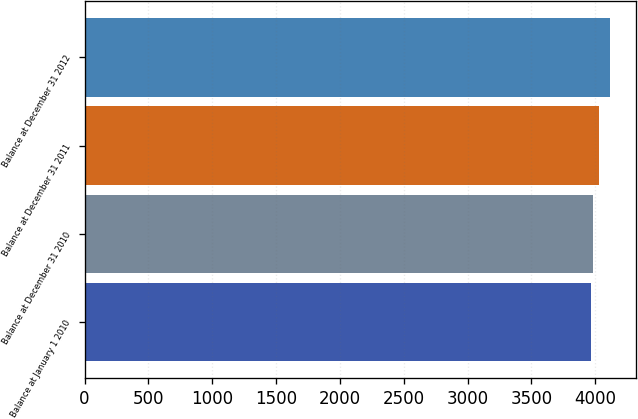Convert chart. <chart><loc_0><loc_0><loc_500><loc_500><bar_chart><fcel>Balance at January 1 2010<fcel>Balance at December 31 2010<fcel>Balance at December 31 2011<fcel>Balance at December 31 2012<nl><fcel>3968<fcel>3985<fcel>4031<fcel>4113<nl></chart> 